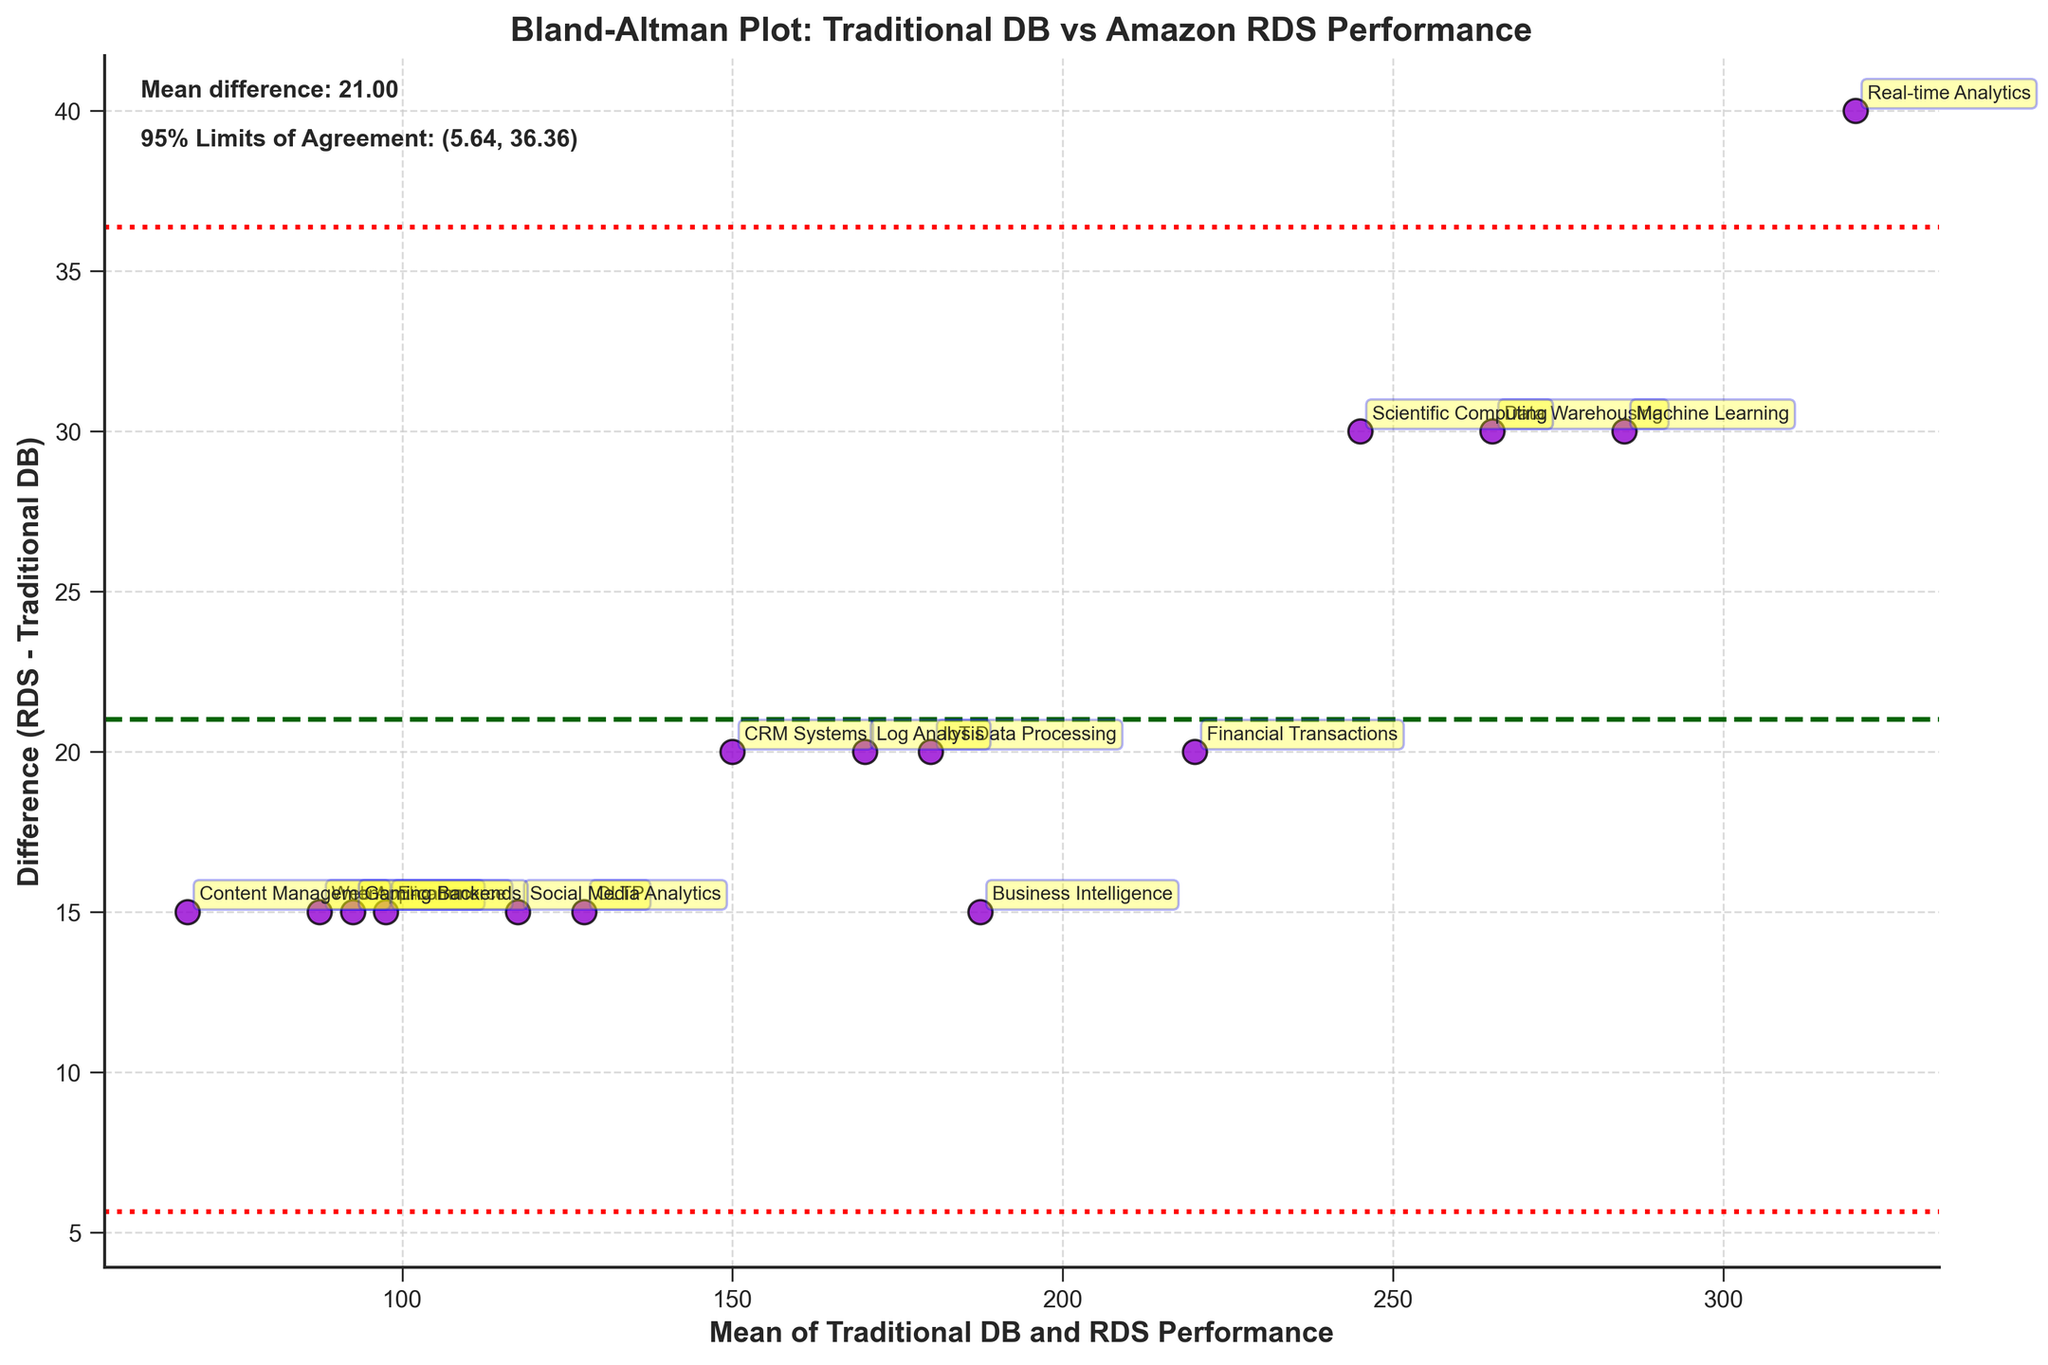How many types of workloads are present in the data? Identify the number of unique workload types by examining the annotations beside each data point. Count the distinct labels.
Answer: 15 What are the axes labeled on the plot? Look at the titles on the x-axis and y-axis. The x-axis represents the mean of Traditional DB and RDS Performance, and the y-axis represents the difference (RDS - Traditional DB).
Answer: Mean of Traditional DB and RDS Performance; Difference (RDS - Traditional DB) What's the title of the plot? Observe the text at the top of the plot. It describes the type of performance comparison and the systems involved.
Answer: Bland-Altman Plot: Traditional DB vs Amazon RDS Performance Which workload type has the highest mean performance? Find the point with the highest x-axis value (mean of Traditional DB and RDS Performance) and check the annotation label next to it.
Answer: Real-time Analytics What's the mean difference between RDS and Traditional DB performance? Locate the horizontal line that represents the mean difference. This line is usually labeled directly on the plot or can be deduced from its placement relative to the data points.
Answer: 24.67 What are the 95% limits of agreement for the performance differences? Identify the two red dashed lines. The limits of agreement are labeled next to these lines, indicating the range for 95% of the data points.
Answer: (7.46, 41.88) Are there any workload types where the RDS outperforms Traditional DB by more than 40 units? Check the y-axis values to see which points have a difference greater than 40 units and look at their annotations.
Answer: Yes, Real-time Analytics Which workload type has the smallest difference in performance between Traditional DB and RDS? Identify the data point closest to y = 0 by examining the y-axis values and check the annotation for the corresponding label.
Answer: Web Applications How does the difference in performance vary across different mean performance levels? Observe the spread of points along the x-axis (mean performance) and the variation in their y-axis (difference) positions. Consider whether there's a trend or pattern visible.
Answer: The difference generally increases with the mean performance level Does the plot indicate any systematic bias between Traditional DB and RDS performance? Examine the placement of the mean difference line relative to the zero line and how the data points are distributed around it. If the mean difference line is significantly above or below zero, there may be indication of a systematic bias.
Answer: Yes, RDS generally performs better 